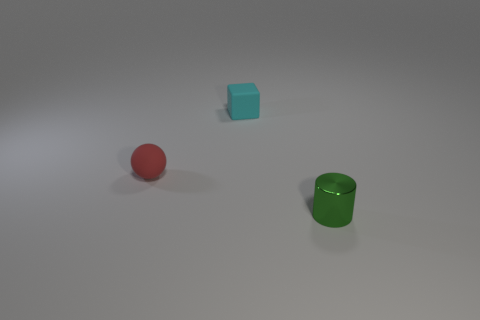Add 2 gray balls. How many objects exist? 5 Subtract all spheres. How many objects are left? 2 Add 3 yellow cylinders. How many yellow cylinders exist? 3 Subtract 0 cyan cylinders. How many objects are left? 3 Subtract all small green objects. Subtract all blocks. How many objects are left? 1 Add 2 metal objects. How many metal objects are left? 3 